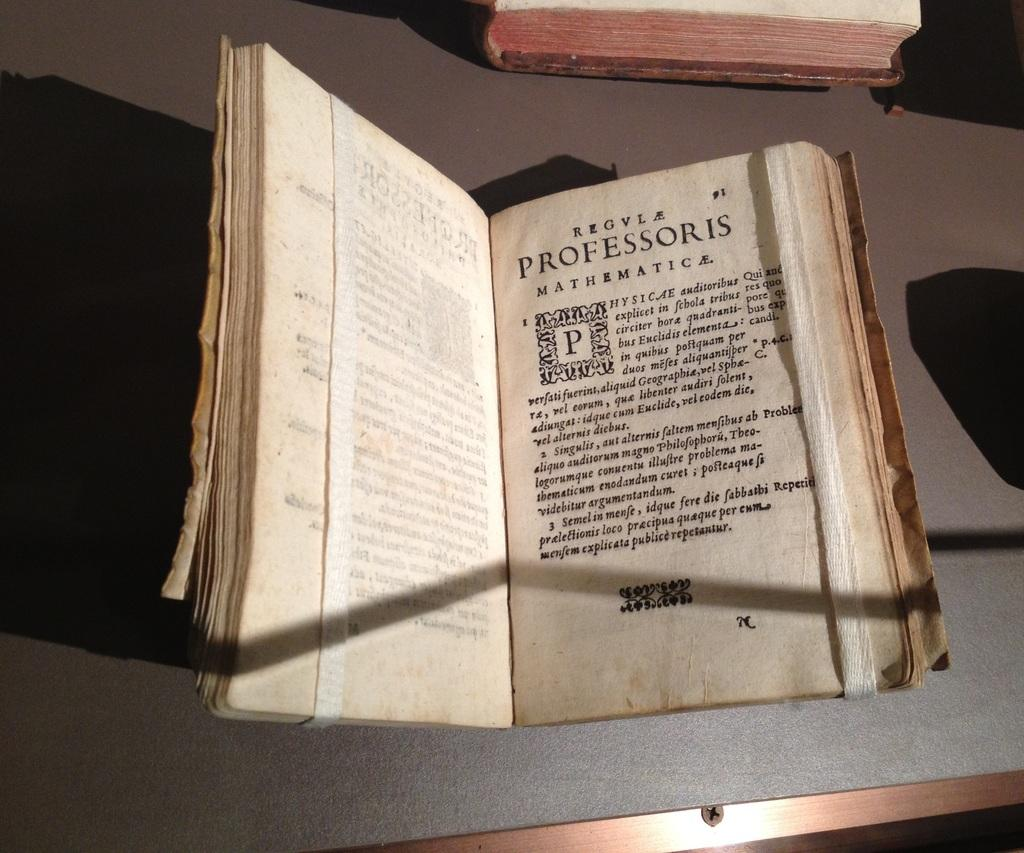How many books are visible in the image? There are 2 books in the image. What else is present on the brown surface with the books? There is a paper with words written on it in the image. What can be observed on the books and paper? Shadows are visible in the image. How many snails can be seen crawling on the books in the image? There are no snails present in the image; it only features books, a paper, and shadows. What is the thumb doing in the image? There is no thumb visible in the image. 